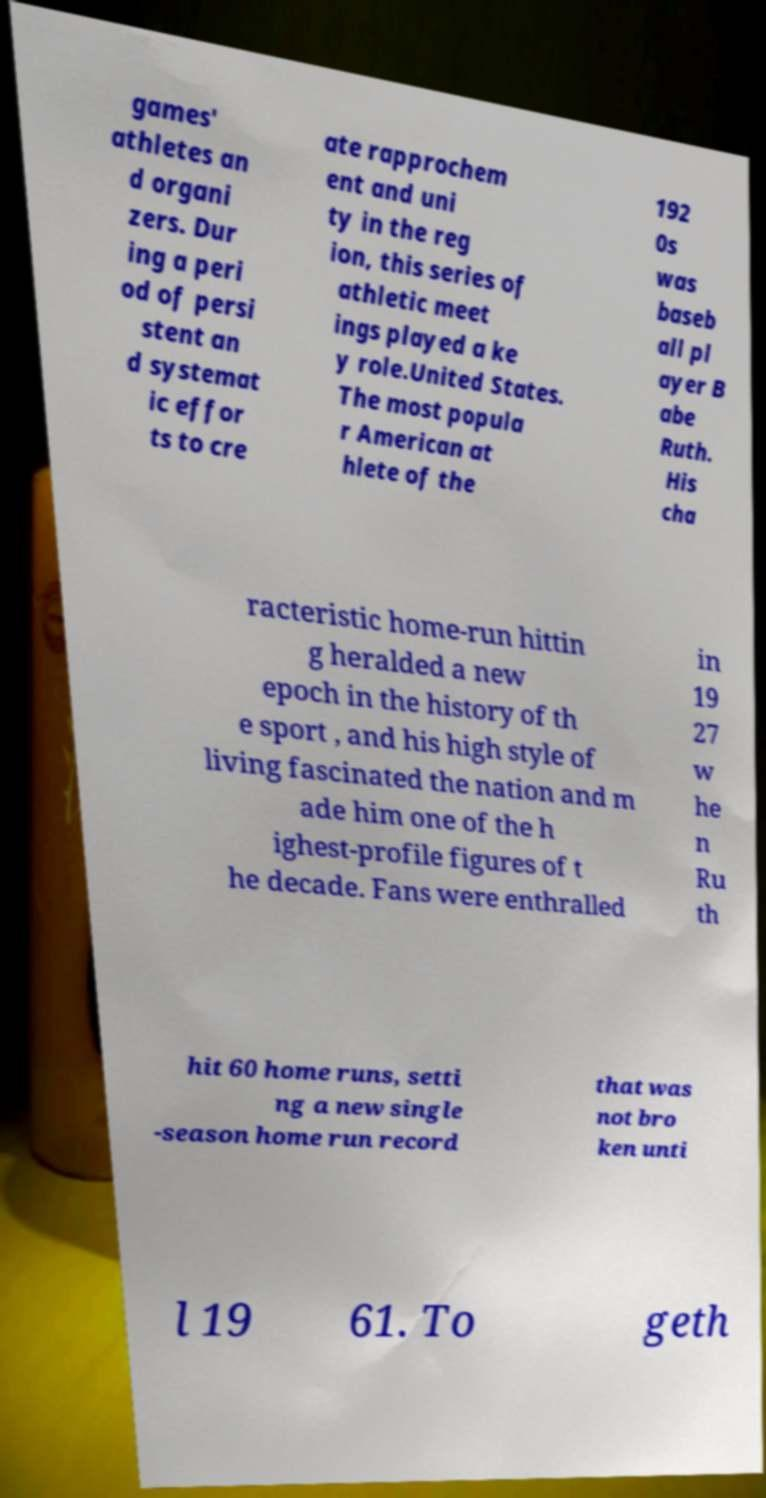Please read and relay the text visible in this image. What does it say? games' athletes an d organi zers. Dur ing a peri od of persi stent an d systemat ic effor ts to cre ate rapprochem ent and uni ty in the reg ion, this series of athletic meet ings played a ke y role.United States. The most popula r American at hlete of the 192 0s was baseb all pl ayer B abe Ruth. His cha racteristic home-run hittin g heralded a new epoch in the history of th e sport , and his high style of living fascinated the nation and m ade him one of the h ighest-profile figures of t he decade. Fans were enthralled in 19 27 w he n Ru th hit 60 home runs, setti ng a new single -season home run record that was not bro ken unti l 19 61. To geth 